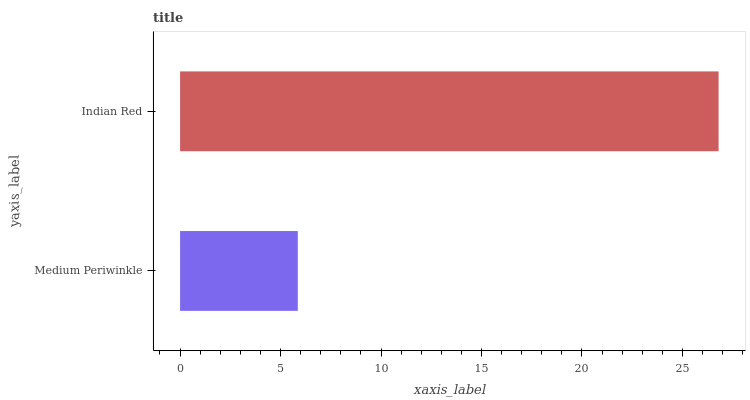Is Medium Periwinkle the minimum?
Answer yes or no. Yes. Is Indian Red the maximum?
Answer yes or no. Yes. Is Indian Red the minimum?
Answer yes or no. No. Is Indian Red greater than Medium Periwinkle?
Answer yes or no. Yes. Is Medium Periwinkle less than Indian Red?
Answer yes or no. Yes. Is Medium Periwinkle greater than Indian Red?
Answer yes or no. No. Is Indian Red less than Medium Periwinkle?
Answer yes or no. No. Is Indian Red the high median?
Answer yes or no. Yes. Is Medium Periwinkle the low median?
Answer yes or no. Yes. Is Medium Periwinkle the high median?
Answer yes or no. No. Is Indian Red the low median?
Answer yes or no. No. 